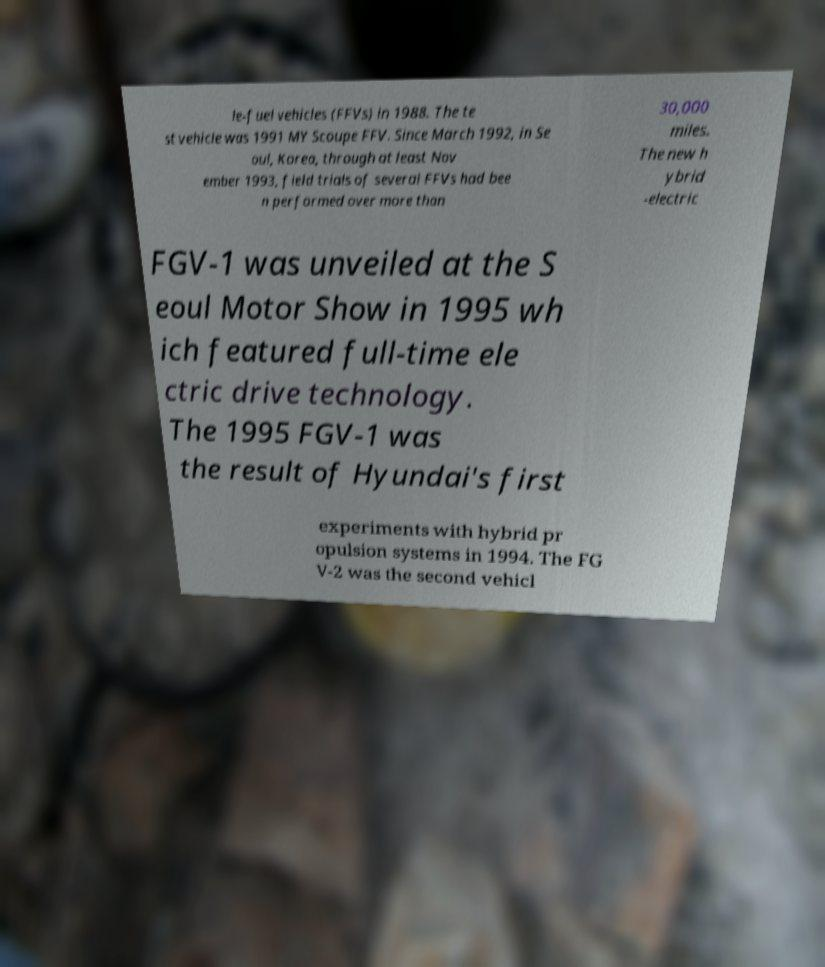Please identify and transcribe the text found in this image. le-fuel vehicles (FFVs) in 1988. The te st vehicle was 1991 MY Scoupe FFV. Since March 1992, in Se oul, Korea, through at least Nov ember 1993, field trials of several FFVs had bee n performed over more than 30,000 miles. The new h ybrid -electric FGV-1 was unveiled at the S eoul Motor Show in 1995 wh ich featured full-time ele ctric drive technology. The 1995 FGV-1 was the result of Hyundai's first experiments with hybrid pr opulsion systems in 1994. The FG V-2 was the second vehicl 